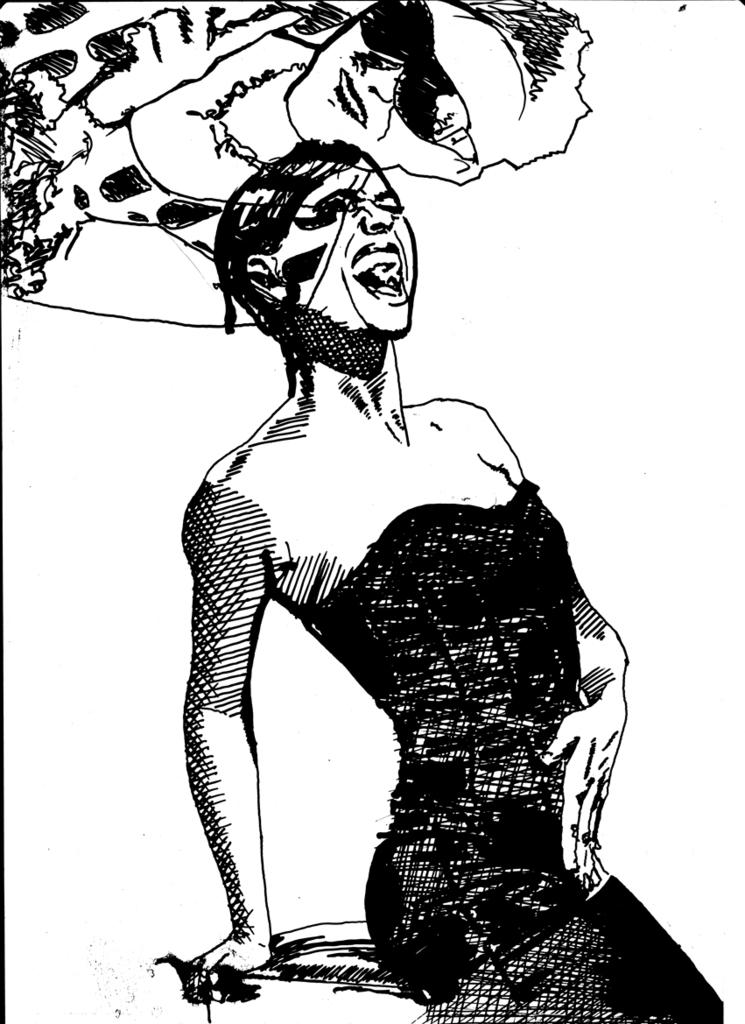What type of image is shown in the picture? The image is a sketch print. What is the main subject of the sketch print? There is a lady depicted in the image. Are there any other subjects in the sketch print? Yes, there is another lady depicted above the first lady. How many snakes are wrapped around the lady in the image? There are no snakes present in the image; it depicts two ladies. What type of stone is used to create the background of the image? The image is a sketch print, and there is no mention of stone being used in its creation. 